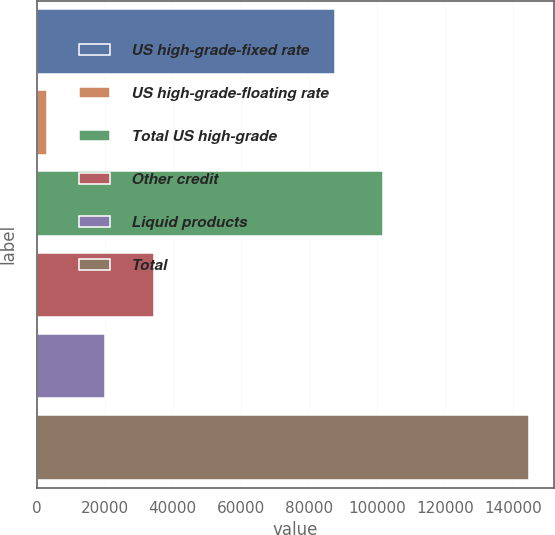<chart> <loc_0><loc_0><loc_500><loc_500><bar_chart><fcel>US high-grade-fixed rate<fcel>US high-grade-floating rate<fcel>Total US high-grade<fcel>Other credit<fcel>Liquid products<fcel>Total<nl><fcel>87686<fcel>2984<fcel>101865<fcel>34379.2<fcel>20200<fcel>144776<nl></chart> 